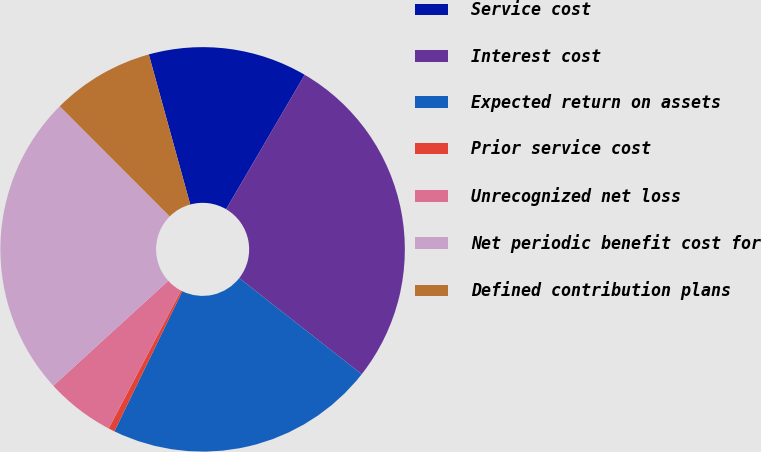<chart> <loc_0><loc_0><loc_500><loc_500><pie_chart><fcel>Service cost<fcel>Interest cost<fcel>Expected return on assets<fcel>Prior service cost<fcel>Unrecognized net loss<fcel>Net periodic benefit cost for<fcel>Defined contribution plans<nl><fcel>12.71%<fcel>27.17%<fcel>21.6%<fcel>0.5%<fcel>5.53%<fcel>24.3%<fcel>8.2%<nl></chart> 